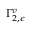<formula> <loc_0><loc_0><loc_500><loc_500>\Gamma _ { 2 , \epsilon } ^ { v }</formula> 